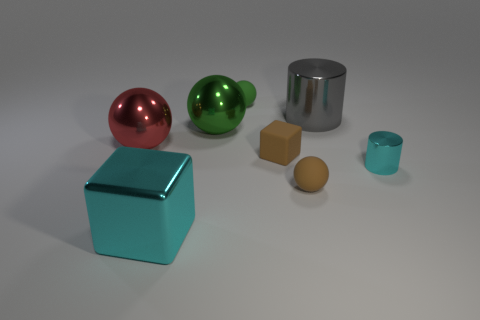There is a metal object that is behind the red thing and right of the big green sphere; what is its size?
Provide a succinct answer. Large. What shape is the shiny object that is in front of the matte cube and left of the big cylinder?
Make the answer very short. Cube. What material is the thing that is the same color as the small shiny cylinder?
Provide a short and direct response. Metal. What is the size of the metal cylinder that is the same color as the large cube?
Your answer should be very brief. Small. Are there fewer matte cubes that are in front of the small cyan metallic object than big spheres that are behind the large cyan object?
Your response must be concise. Yes. Do the gray cylinder and the block that is on the right side of the large block have the same material?
Your response must be concise. No. Is the number of spheres greater than the number of things?
Offer a terse response. No. What shape is the big metallic thing in front of the cyan object that is to the right of the tiny brown object that is behind the small cyan metal thing?
Your answer should be very brief. Cube. Are the big cyan cube that is on the left side of the large gray shiny cylinder and the cylinder that is in front of the big gray shiny thing made of the same material?
Keep it short and to the point. Yes. The small object that is made of the same material as the large red ball is what shape?
Provide a short and direct response. Cylinder. 